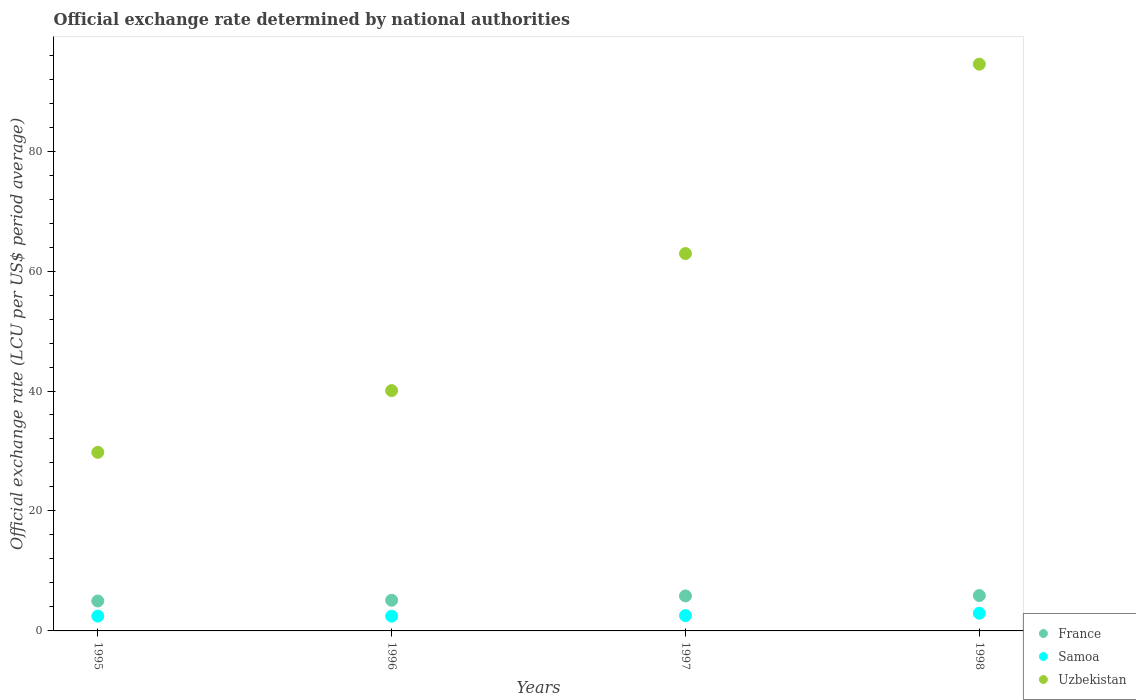Is the number of dotlines equal to the number of legend labels?
Offer a terse response. Yes. What is the official exchange rate in Samoa in 1996?
Provide a short and direct response. 2.46. Across all years, what is the maximum official exchange rate in France?
Give a very brief answer. 5.9. Across all years, what is the minimum official exchange rate in France?
Give a very brief answer. 4.99. In which year was the official exchange rate in France maximum?
Give a very brief answer. 1998. In which year was the official exchange rate in France minimum?
Your answer should be very brief. 1995. What is the total official exchange rate in Samoa in the graph?
Provide a short and direct response. 10.44. What is the difference between the official exchange rate in Uzbekistan in 1995 and that in 1998?
Offer a very short reply. -64.72. What is the difference between the official exchange rate in France in 1998 and the official exchange rate in Samoa in 1996?
Provide a succinct answer. 3.44. What is the average official exchange rate in Uzbekistan per year?
Give a very brief answer. 56.81. In the year 1997, what is the difference between the official exchange rate in Uzbekistan and official exchange rate in Samoa?
Offer a very short reply. 60.36. In how many years, is the official exchange rate in Samoa greater than 64 LCU?
Ensure brevity in your answer.  0. What is the ratio of the official exchange rate in Samoa in 1997 to that in 1998?
Provide a succinct answer. 0.87. Is the difference between the official exchange rate in Uzbekistan in 1995 and 1996 greater than the difference between the official exchange rate in Samoa in 1995 and 1996?
Your answer should be very brief. No. What is the difference between the highest and the second highest official exchange rate in Samoa?
Your answer should be very brief. 0.39. What is the difference between the highest and the lowest official exchange rate in France?
Give a very brief answer. 0.91. In how many years, is the official exchange rate in Samoa greater than the average official exchange rate in Samoa taken over all years?
Your response must be concise. 1. Is the sum of the official exchange rate in France in 1996 and 1998 greater than the maximum official exchange rate in Samoa across all years?
Your answer should be compact. Yes. Is it the case that in every year, the sum of the official exchange rate in France and official exchange rate in Samoa  is greater than the official exchange rate in Uzbekistan?
Provide a short and direct response. No. Does the official exchange rate in Samoa monotonically increase over the years?
Your answer should be compact. No. Is the official exchange rate in Samoa strictly greater than the official exchange rate in Uzbekistan over the years?
Make the answer very short. No. Is the official exchange rate in Samoa strictly less than the official exchange rate in Uzbekistan over the years?
Your response must be concise. Yes. How many years are there in the graph?
Provide a succinct answer. 4. What is the difference between two consecutive major ticks on the Y-axis?
Your response must be concise. 20. Does the graph contain any zero values?
Keep it short and to the point. No. Does the graph contain grids?
Offer a terse response. No. Where does the legend appear in the graph?
Offer a very short reply. Bottom right. How many legend labels are there?
Your answer should be very brief. 3. What is the title of the graph?
Offer a terse response. Official exchange rate determined by national authorities. What is the label or title of the X-axis?
Make the answer very short. Years. What is the label or title of the Y-axis?
Give a very brief answer. Official exchange rate (LCU per US$ period average). What is the Official exchange rate (LCU per US$ period average) in France in 1995?
Your answer should be very brief. 4.99. What is the Official exchange rate (LCU per US$ period average) of Samoa in 1995?
Offer a terse response. 2.47. What is the Official exchange rate (LCU per US$ period average) of Uzbekistan in 1995?
Your response must be concise. 29.77. What is the Official exchange rate (LCU per US$ period average) in France in 1996?
Offer a very short reply. 5.12. What is the Official exchange rate (LCU per US$ period average) in Samoa in 1996?
Offer a very short reply. 2.46. What is the Official exchange rate (LCU per US$ period average) of Uzbekistan in 1996?
Provide a succinct answer. 40.07. What is the Official exchange rate (LCU per US$ period average) in France in 1997?
Offer a very short reply. 5.84. What is the Official exchange rate (LCU per US$ period average) in Samoa in 1997?
Provide a short and direct response. 2.56. What is the Official exchange rate (LCU per US$ period average) of Uzbekistan in 1997?
Offer a very short reply. 62.92. What is the Official exchange rate (LCU per US$ period average) in France in 1998?
Offer a very short reply. 5.9. What is the Official exchange rate (LCU per US$ period average) in Samoa in 1998?
Make the answer very short. 2.95. What is the Official exchange rate (LCU per US$ period average) in Uzbekistan in 1998?
Make the answer very short. 94.49. Across all years, what is the maximum Official exchange rate (LCU per US$ period average) in France?
Give a very brief answer. 5.9. Across all years, what is the maximum Official exchange rate (LCU per US$ period average) in Samoa?
Make the answer very short. 2.95. Across all years, what is the maximum Official exchange rate (LCU per US$ period average) of Uzbekistan?
Keep it short and to the point. 94.49. Across all years, what is the minimum Official exchange rate (LCU per US$ period average) of France?
Keep it short and to the point. 4.99. Across all years, what is the minimum Official exchange rate (LCU per US$ period average) in Samoa?
Your response must be concise. 2.46. Across all years, what is the minimum Official exchange rate (LCU per US$ period average) of Uzbekistan?
Offer a terse response. 29.77. What is the total Official exchange rate (LCU per US$ period average) in France in the graph?
Ensure brevity in your answer.  21.84. What is the total Official exchange rate (LCU per US$ period average) in Samoa in the graph?
Ensure brevity in your answer.  10.44. What is the total Official exchange rate (LCU per US$ period average) of Uzbekistan in the graph?
Offer a terse response. 227.25. What is the difference between the Official exchange rate (LCU per US$ period average) in France in 1995 and that in 1996?
Offer a terse response. -0.12. What is the difference between the Official exchange rate (LCU per US$ period average) in Samoa in 1995 and that in 1996?
Offer a very short reply. 0.01. What is the difference between the Official exchange rate (LCU per US$ period average) in Uzbekistan in 1995 and that in 1996?
Your response must be concise. -10.29. What is the difference between the Official exchange rate (LCU per US$ period average) in France in 1995 and that in 1997?
Offer a very short reply. -0.85. What is the difference between the Official exchange rate (LCU per US$ period average) of Samoa in 1995 and that in 1997?
Provide a succinct answer. -0.09. What is the difference between the Official exchange rate (LCU per US$ period average) in Uzbekistan in 1995 and that in 1997?
Provide a short and direct response. -33.14. What is the difference between the Official exchange rate (LCU per US$ period average) in France in 1995 and that in 1998?
Offer a terse response. -0.91. What is the difference between the Official exchange rate (LCU per US$ period average) in Samoa in 1995 and that in 1998?
Ensure brevity in your answer.  -0.47. What is the difference between the Official exchange rate (LCU per US$ period average) in Uzbekistan in 1995 and that in 1998?
Provide a succinct answer. -64.72. What is the difference between the Official exchange rate (LCU per US$ period average) of France in 1996 and that in 1997?
Offer a very short reply. -0.72. What is the difference between the Official exchange rate (LCU per US$ period average) of Samoa in 1996 and that in 1997?
Ensure brevity in your answer.  -0.1. What is the difference between the Official exchange rate (LCU per US$ period average) in Uzbekistan in 1996 and that in 1997?
Offer a very short reply. -22.85. What is the difference between the Official exchange rate (LCU per US$ period average) in France in 1996 and that in 1998?
Offer a terse response. -0.78. What is the difference between the Official exchange rate (LCU per US$ period average) of Samoa in 1996 and that in 1998?
Make the answer very short. -0.49. What is the difference between the Official exchange rate (LCU per US$ period average) of Uzbekistan in 1996 and that in 1998?
Keep it short and to the point. -54.42. What is the difference between the Official exchange rate (LCU per US$ period average) in France in 1997 and that in 1998?
Provide a succinct answer. -0.06. What is the difference between the Official exchange rate (LCU per US$ period average) in Samoa in 1997 and that in 1998?
Keep it short and to the point. -0.39. What is the difference between the Official exchange rate (LCU per US$ period average) in Uzbekistan in 1997 and that in 1998?
Give a very brief answer. -31.57. What is the difference between the Official exchange rate (LCU per US$ period average) in France in 1995 and the Official exchange rate (LCU per US$ period average) in Samoa in 1996?
Provide a short and direct response. 2.53. What is the difference between the Official exchange rate (LCU per US$ period average) in France in 1995 and the Official exchange rate (LCU per US$ period average) in Uzbekistan in 1996?
Give a very brief answer. -35.08. What is the difference between the Official exchange rate (LCU per US$ period average) in Samoa in 1995 and the Official exchange rate (LCU per US$ period average) in Uzbekistan in 1996?
Ensure brevity in your answer.  -37.59. What is the difference between the Official exchange rate (LCU per US$ period average) in France in 1995 and the Official exchange rate (LCU per US$ period average) in Samoa in 1997?
Provide a succinct answer. 2.43. What is the difference between the Official exchange rate (LCU per US$ period average) in France in 1995 and the Official exchange rate (LCU per US$ period average) in Uzbekistan in 1997?
Your response must be concise. -57.93. What is the difference between the Official exchange rate (LCU per US$ period average) in Samoa in 1995 and the Official exchange rate (LCU per US$ period average) in Uzbekistan in 1997?
Give a very brief answer. -60.44. What is the difference between the Official exchange rate (LCU per US$ period average) of France in 1995 and the Official exchange rate (LCU per US$ period average) of Samoa in 1998?
Ensure brevity in your answer.  2.04. What is the difference between the Official exchange rate (LCU per US$ period average) of France in 1995 and the Official exchange rate (LCU per US$ period average) of Uzbekistan in 1998?
Ensure brevity in your answer.  -89.5. What is the difference between the Official exchange rate (LCU per US$ period average) in Samoa in 1995 and the Official exchange rate (LCU per US$ period average) in Uzbekistan in 1998?
Ensure brevity in your answer.  -92.02. What is the difference between the Official exchange rate (LCU per US$ period average) in France in 1996 and the Official exchange rate (LCU per US$ period average) in Samoa in 1997?
Ensure brevity in your answer.  2.56. What is the difference between the Official exchange rate (LCU per US$ period average) in France in 1996 and the Official exchange rate (LCU per US$ period average) in Uzbekistan in 1997?
Your response must be concise. -57.8. What is the difference between the Official exchange rate (LCU per US$ period average) in Samoa in 1996 and the Official exchange rate (LCU per US$ period average) in Uzbekistan in 1997?
Offer a very short reply. -60.45. What is the difference between the Official exchange rate (LCU per US$ period average) in France in 1996 and the Official exchange rate (LCU per US$ period average) in Samoa in 1998?
Your answer should be compact. 2.17. What is the difference between the Official exchange rate (LCU per US$ period average) in France in 1996 and the Official exchange rate (LCU per US$ period average) in Uzbekistan in 1998?
Keep it short and to the point. -89.38. What is the difference between the Official exchange rate (LCU per US$ period average) of Samoa in 1996 and the Official exchange rate (LCU per US$ period average) of Uzbekistan in 1998?
Make the answer very short. -92.03. What is the difference between the Official exchange rate (LCU per US$ period average) in France in 1997 and the Official exchange rate (LCU per US$ period average) in Samoa in 1998?
Your answer should be compact. 2.89. What is the difference between the Official exchange rate (LCU per US$ period average) in France in 1997 and the Official exchange rate (LCU per US$ period average) in Uzbekistan in 1998?
Ensure brevity in your answer.  -88.66. What is the difference between the Official exchange rate (LCU per US$ period average) of Samoa in 1997 and the Official exchange rate (LCU per US$ period average) of Uzbekistan in 1998?
Offer a very short reply. -91.93. What is the average Official exchange rate (LCU per US$ period average) of France per year?
Give a very brief answer. 5.46. What is the average Official exchange rate (LCU per US$ period average) of Samoa per year?
Provide a short and direct response. 2.61. What is the average Official exchange rate (LCU per US$ period average) of Uzbekistan per year?
Ensure brevity in your answer.  56.81. In the year 1995, what is the difference between the Official exchange rate (LCU per US$ period average) in France and Official exchange rate (LCU per US$ period average) in Samoa?
Your response must be concise. 2.52. In the year 1995, what is the difference between the Official exchange rate (LCU per US$ period average) in France and Official exchange rate (LCU per US$ period average) in Uzbekistan?
Ensure brevity in your answer.  -24.78. In the year 1995, what is the difference between the Official exchange rate (LCU per US$ period average) in Samoa and Official exchange rate (LCU per US$ period average) in Uzbekistan?
Provide a short and direct response. -27.3. In the year 1996, what is the difference between the Official exchange rate (LCU per US$ period average) of France and Official exchange rate (LCU per US$ period average) of Samoa?
Your answer should be compact. 2.65. In the year 1996, what is the difference between the Official exchange rate (LCU per US$ period average) of France and Official exchange rate (LCU per US$ period average) of Uzbekistan?
Your answer should be compact. -34.95. In the year 1996, what is the difference between the Official exchange rate (LCU per US$ period average) of Samoa and Official exchange rate (LCU per US$ period average) of Uzbekistan?
Ensure brevity in your answer.  -37.6. In the year 1997, what is the difference between the Official exchange rate (LCU per US$ period average) of France and Official exchange rate (LCU per US$ period average) of Samoa?
Your answer should be very brief. 3.28. In the year 1997, what is the difference between the Official exchange rate (LCU per US$ period average) of France and Official exchange rate (LCU per US$ period average) of Uzbekistan?
Your answer should be very brief. -57.08. In the year 1997, what is the difference between the Official exchange rate (LCU per US$ period average) in Samoa and Official exchange rate (LCU per US$ period average) in Uzbekistan?
Keep it short and to the point. -60.36. In the year 1998, what is the difference between the Official exchange rate (LCU per US$ period average) in France and Official exchange rate (LCU per US$ period average) in Samoa?
Your answer should be compact. 2.95. In the year 1998, what is the difference between the Official exchange rate (LCU per US$ period average) of France and Official exchange rate (LCU per US$ period average) of Uzbekistan?
Give a very brief answer. -88.59. In the year 1998, what is the difference between the Official exchange rate (LCU per US$ period average) of Samoa and Official exchange rate (LCU per US$ period average) of Uzbekistan?
Offer a terse response. -91.54. What is the ratio of the Official exchange rate (LCU per US$ period average) of France in 1995 to that in 1996?
Offer a terse response. 0.98. What is the ratio of the Official exchange rate (LCU per US$ period average) in Samoa in 1995 to that in 1996?
Offer a terse response. 1. What is the ratio of the Official exchange rate (LCU per US$ period average) in Uzbekistan in 1995 to that in 1996?
Give a very brief answer. 0.74. What is the ratio of the Official exchange rate (LCU per US$ period average) in France in 1995 to that in 1997?
Ensure brevity in your answer.  0.86. What is the ratio of the Official exchange rate (LCU per US$ period average) in Samoa in 1995 to that in 1997?
Ensure brevity in your answer.  0.97. What is the ratio of the Official exchange rate (LCU per US$ period average) of Uzbekistan in 1995 to that in 1997?
Offer a terse response. 0.47. What is the ratio of the Official exchange rate (LCU per US$ period average) of France in 1995 to that in 1998?
Keep it short and to the point. 0.85. What is the ratio of the Official exchange rate (LCU per US$ period average) of Samoa in 1995 to that in 1998?
Offer a terse response. 0.84. What is the ratio of the Official exchange rate (LCU per US$ period average) in Uzbekistan in 1995 to that in 1998?
Offer a terse response. 0.32. What is the ratio of the Official exchange rate (LCU per US$ period average) of France in 1996 to that in 1997?
Give a very brief answer. 0.88. What is the ratio of the Official exchange rate (LCU per US$ period average) of Uzbekistan in 1996 to that in 1997?
Give a very brief answer. 0.64. What is the ratio of the Official exchange rate (LCU per US$ period average) of France in 1996 to that in 1998?
Provide a succinct answer. 0.87. What is the ratio of the Official exchange rate (LCU per US$ period average) in Samoa in 1996 to that in 1998?
Your answer should be very brief. 0.84. What is the ratio of the Official exchange rate (LCU per US$ period average) in Uzbekistan in 1996 to that in 1998?
Give a very brief answer. 0.42. What is the ratio of the Official exchange rate (LCU per US$ period average) in France in 1997 to that in 1998?
Give a very brief answer. 0.99. What is the ratio of the Official exchange rate (LCU per US$ period average) in Samoa in 1997 to that in 1998?
Make the answer very short. 0.87. What is the ratio of the Official exchange rate (LCU per US$ period average) in Uzbekistan in 1997 to that in 1998?
Give a very brief answer. 0.67. What is the difference between the highest and the second highest Official exchange rate (LCU per US$ period average) of France?
Offer a terse response. 0.06. What is the difference between the highest and the second highest Official exchange rate (LCU per US$ period average) in Samoa?
Offer a terse response. 0.39. What is the difference between the highest and the second highest Official exchange rate (LCU per US$ period average) in Uzbekistan?
Give a very brief answer. 31.57. What is the difference between the highest and the lowest Official exchange rate (LCU per US$ period average) of France?
Provide a succinct answer. 0.91. What is the difference between the highest and the lowest Official exchange rate (LCU per US$ period average) in Samoa?
Offer a terse response. 0.49. What is the difference between the highest and the lowest Official exchange rate (LCU per US$ period average) of Uzbekistan?
Offer a very short reply. 64.72. 